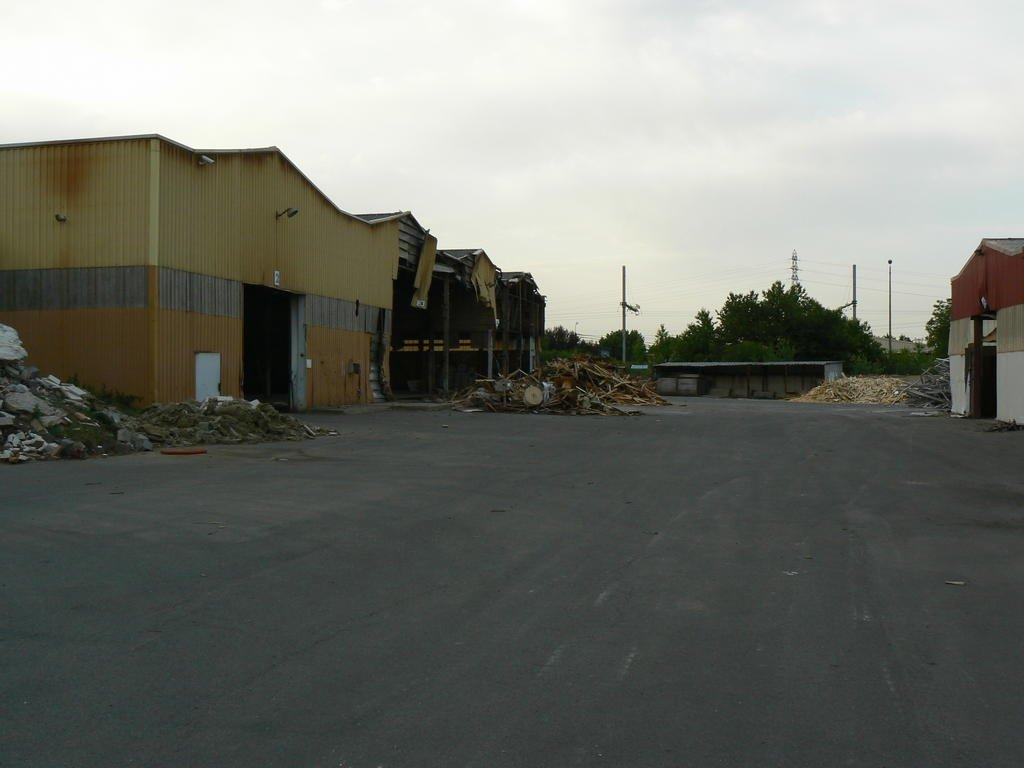What type of structures can be seen in the image? There are sheds in the image. What objects are present on the road in the image? There are sticks on the road in the image. What type of natural elements are visible in the image? There are stones and trees in the image. What type of communication device can be seen in the image? There is an antenna in the image. What type of vertical structures are present in the image? There are poles in the image. What part of the natural environment is visible in the image? The sky is visible in the image. What type of copper material can be seen in the image? There is no copper material present in the image. What type of peace symbol can be seen in the image? There is no peace symbol present in the image. What type of fish can be seen swimming in the image? There is no fish present in the image. 